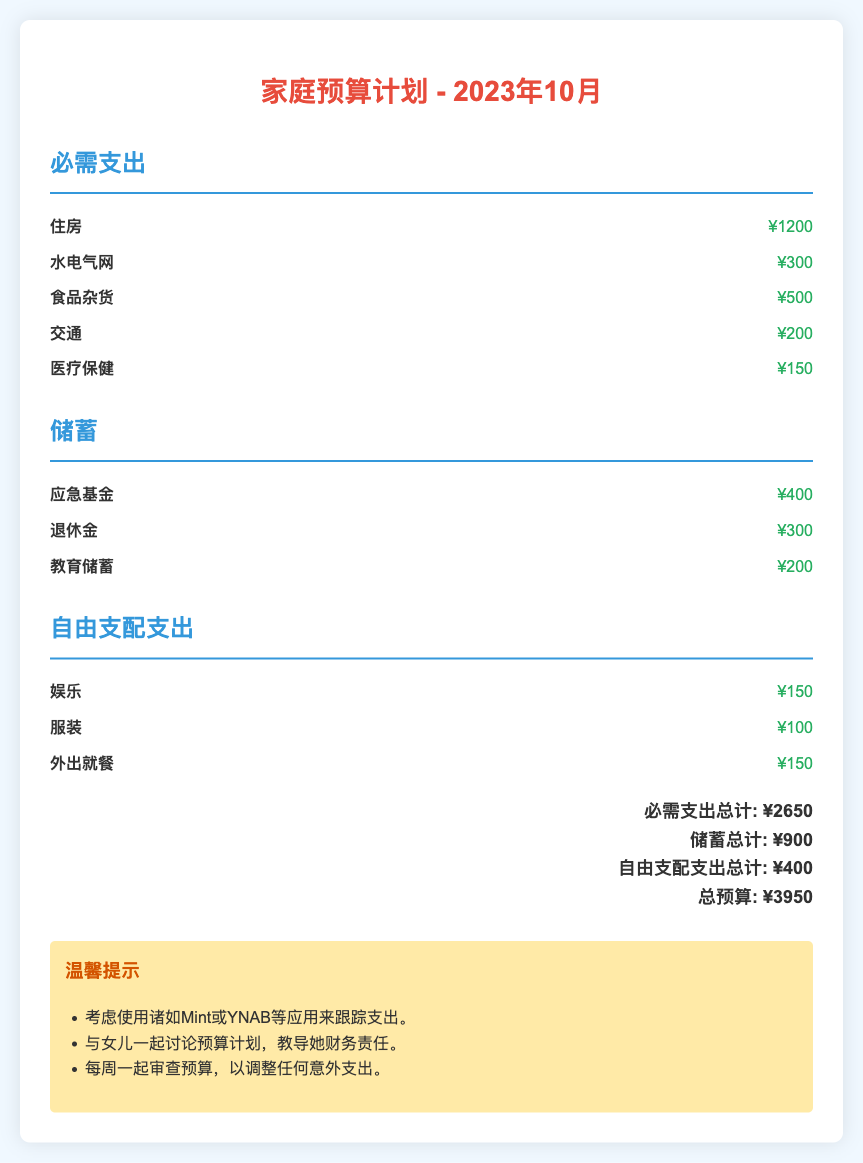what is the total amount allocated for essentials? The total amount for essentials is indicated by the sum of all essential items: ¥1200 + ¥300 + ¥500 + ¥200 + ¥150.
Answer: ¥2650 what is the amount set aside for emergency funds? The emergency fund amount is specified in the savings section of the document.
Answer: ¥400 how much is budgeted for discretionary spending on dining out? The budget for dining out is listed as an item in the discretionary spending category.
Answer: ¥150 what is the total budget for the month of October 2023? The total budget is the sum of all categories: ¥2650 + ¥900 + ¥400.
Answer: ¥3950 how much is allocated for clothing in discretionary spending? The clothing expenditure amount is highlighted in the discretionary spending section.
Answer: ¥100 what is the amount of savings set aside for retirement? The retirement savings amount is detailed in the savings category of the document.
Answer: ¥300 how many categories are outlined in the budget plan? The categories detailed in the budget are essential expenses, savings, and discretionary spending.
Answer: 3 what is the ratio of essential spending to total budget? The essential spending ratio is derived from the total essential amount divided by the total budget: ¥2650/¥3950.
Answer: 67% what is the suggested application for tracking expenses? The application suggested for tracking expenses is mentioned in the tips section.
Answer: Mint or YNAB 